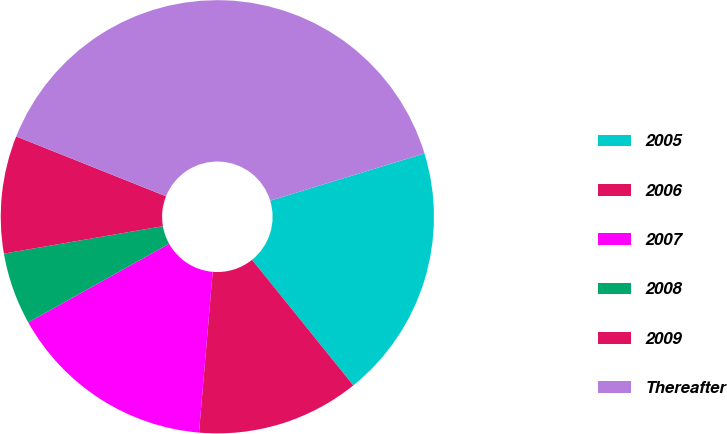Convert chart to OTSL. <chart><loc_0><loc_0><loc_500><loc_500><pie_chart><fcel>2005<fcel>2006<fcel>2007<fcel>2008<fcel>2009<fcel>Thereafter<nl><fcel>18.92%<fcel>12.15%<fcel>15.54%<fcel>5.39%<fcel>8.77%<fcel>39.23%<nl></chart> 